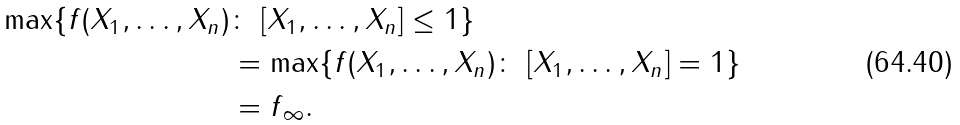Convert formula to latex. <formula><loc_0><loc_0><loc_500><loc_500>\max \{ \| f ( X _ { 1 } , \dots , X _ { n } ) \| & \colon \ \| [ X _ { 1 } , \dots , X _ { n } ] \| \leq 1 \} \\ & = \max \{ \| f ( X _ { 1 } , \dots , X _ { n } ) \| \colon \ \| [ X _ { 1 } , \dots , X _ { n } ] \| = 1 \} \\ & = \| f \| _ { \infty } .</formula> 